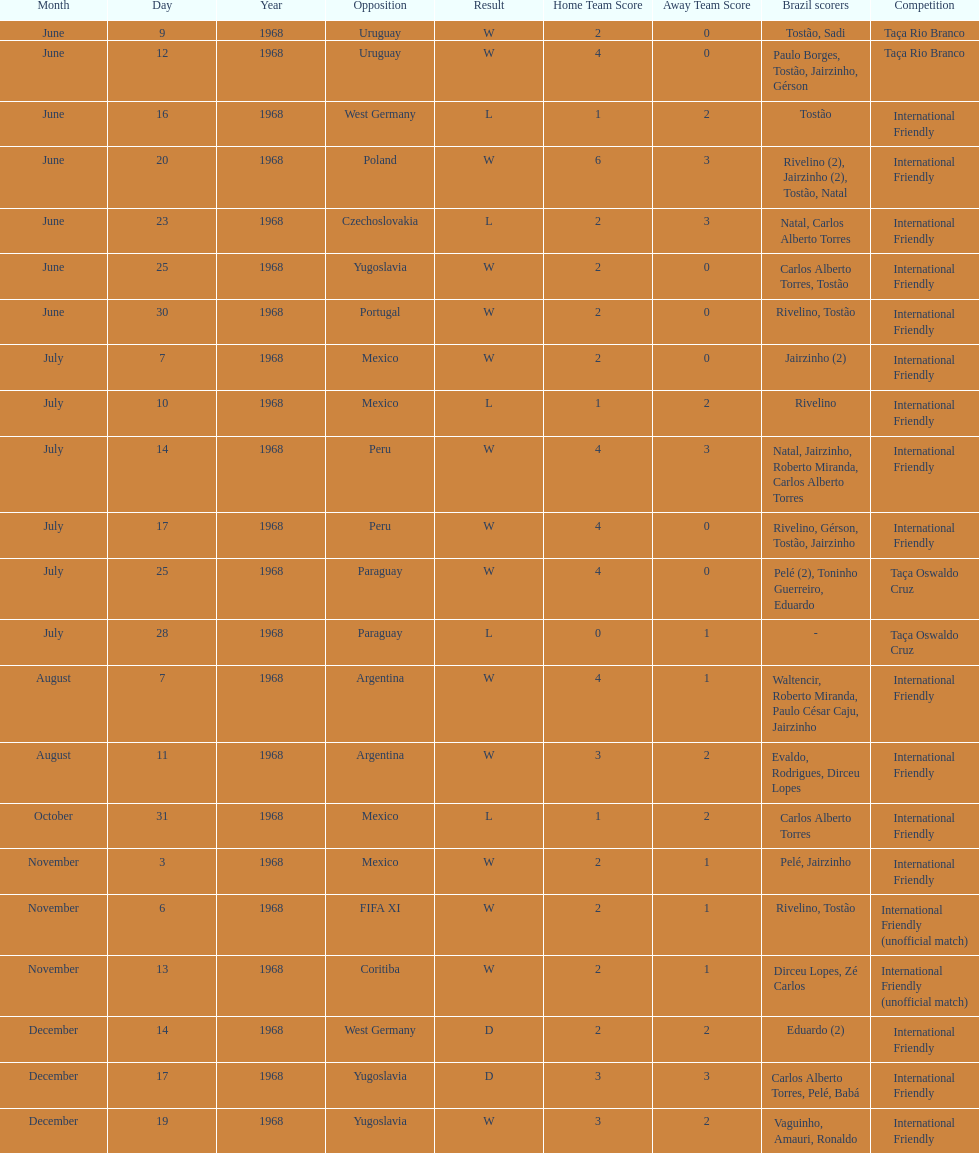Number of losses 5. 